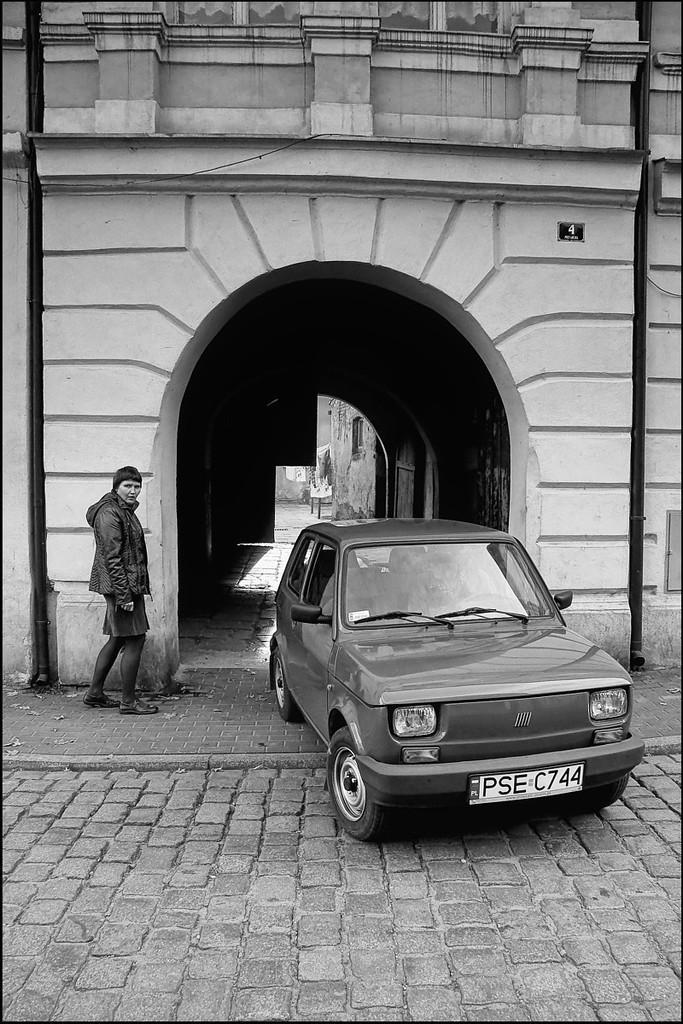Can you describe this image briefly? In this image there is the wall truncated towards the top of the image, there is the wall truncated towards the right of the image, there is the wall truncated towards the left of the image, there is a person standing, there is a car, there is the door, there are objects, there is a board on the wall, there is a number on the board. 